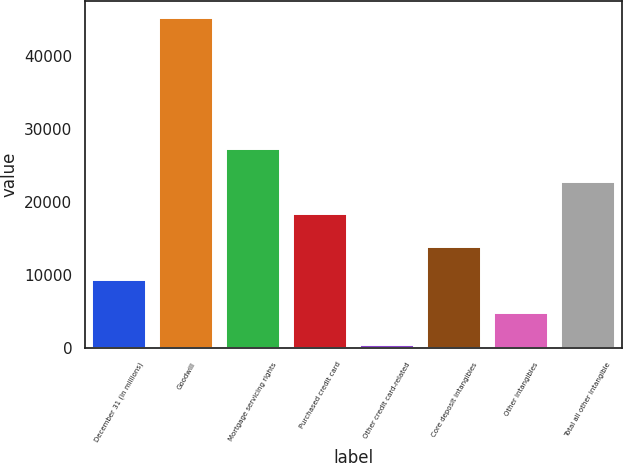<chart> <loc_0><loc_0><loc_500><loc_500><bar_chart><fcel>December 31 (in millions)<fcel>Goodwill<fcel>Mortgage servicing rights<fcel>Purchased credit card<fcel>Other credit card-related<fcel>Core deposit intangibles<fcel>Other intangibles<fcel>Total all other intangible<nl><fcel>9330.8<fcel>45270<fcel>27300.4<fcel>18315.6<fcel>346<fcel>13823.2<fcel>4838.4<fcel>22808<nl></chart> 